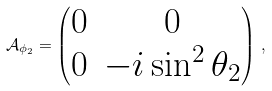<formula> <loc_0><loc_0><loc_500><loc_500>\mathcal { A } _ { \phi _ { 2 } } = \left ( \begin{matrix} 0 & 0 \\ 0 & - i \sin ^ { 2 } \theta _ { 2 } \end{matrix} \right ) \, ,</formula> 